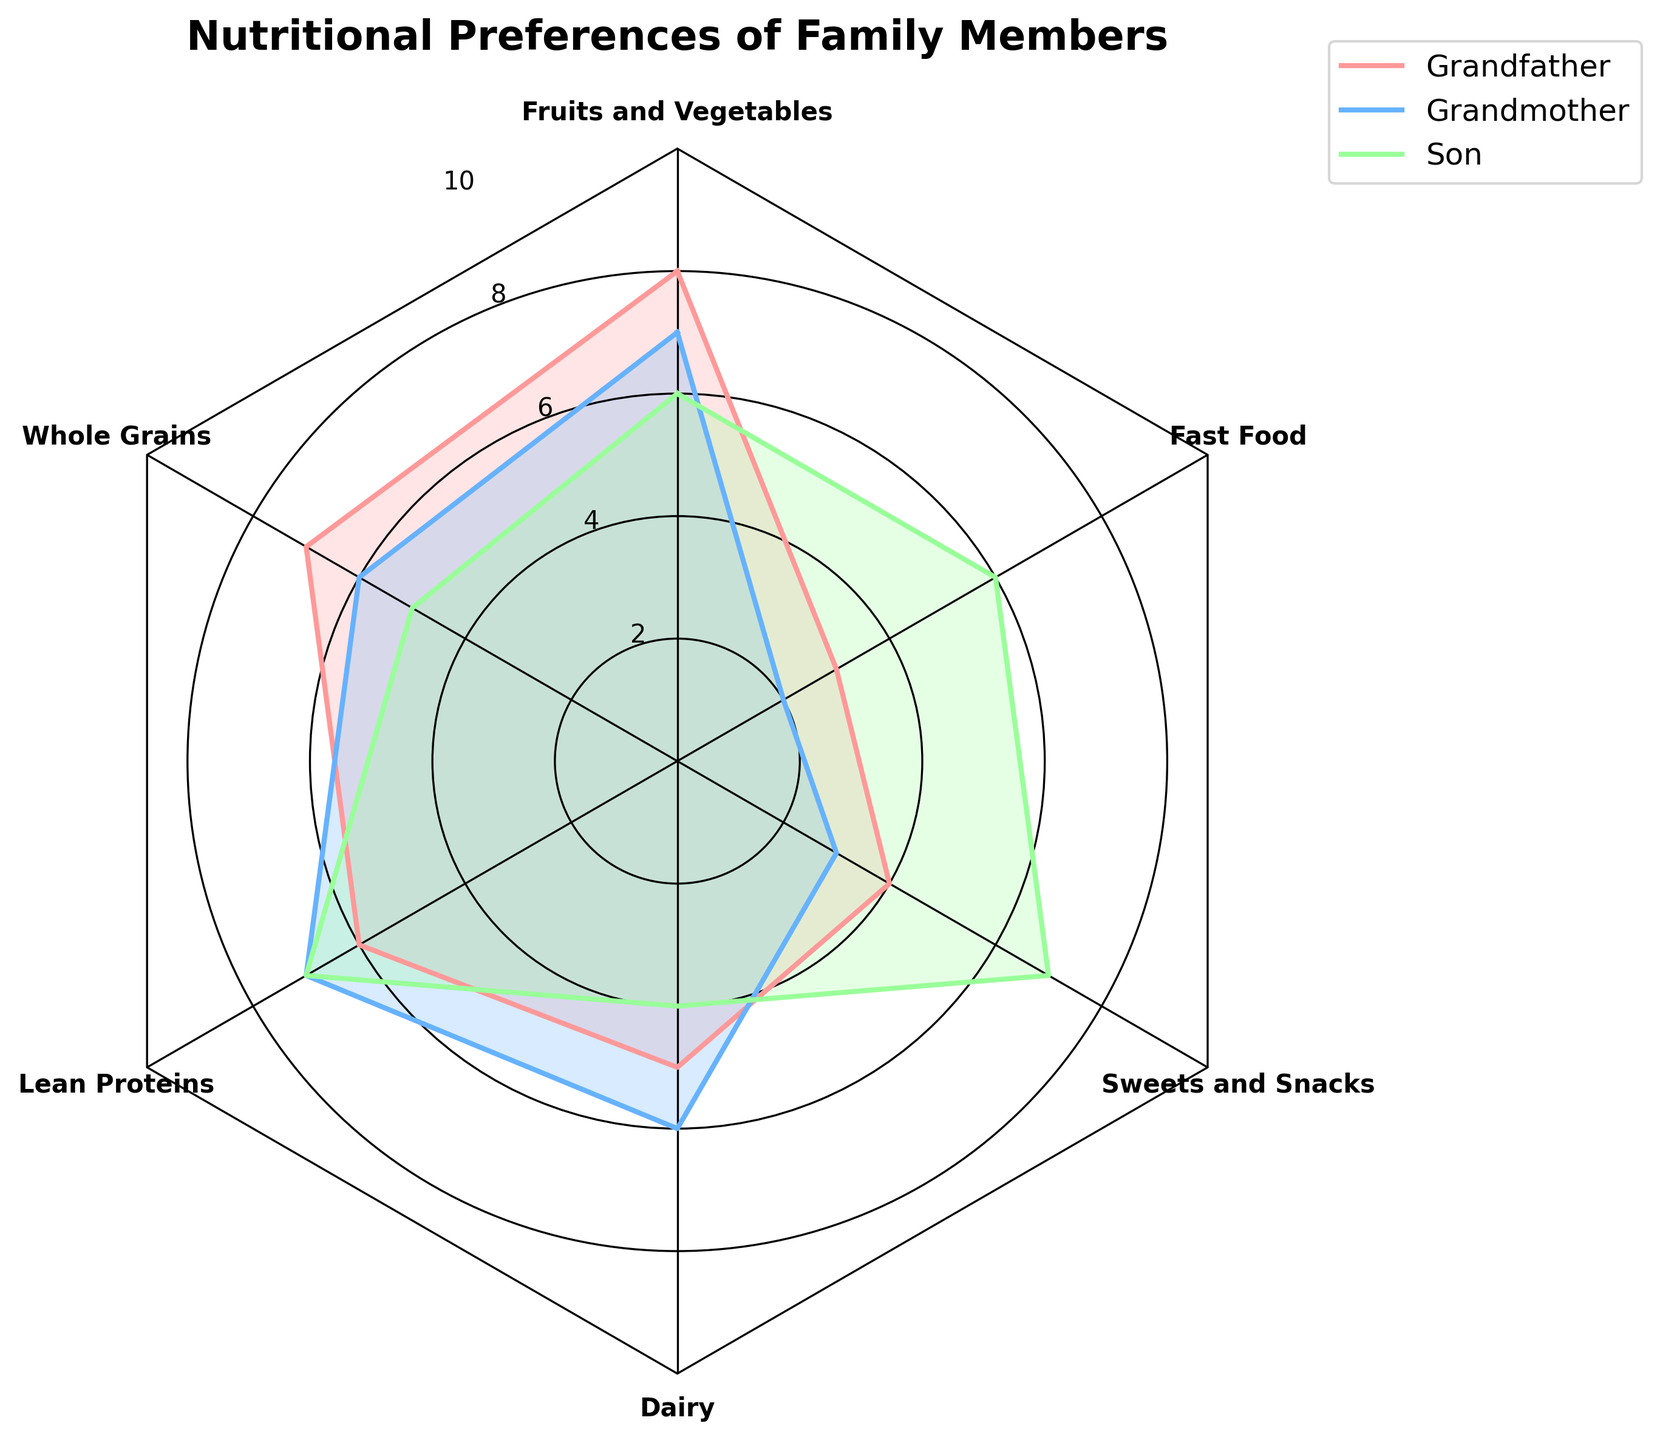How many nutritional preferences are compared in the chart? Count the number of different nutritional preferences listed around the chart.
Answer: 6 What is the highest value for any family member's preference? Identify the highest value among all preferences and family members.
Answer: 8 Which family member has the highest preference for fruits and vegetables? Look for the highest value at the "Fruits and Vegetables" point among all family members.
Answer: Grandfather What is the difference in preferences for fast food between the son and the daughter-in-law? Subtract the daughter's value from the son's value for fast food preference.
Answer: 1 Whose diet has the least preference for sweets and snacks? Find the family member with the lowest value for sweets and snacks.
Answer: Grandmother Which nutritional preference shows the largest range of values among family members? Compute the range (maximum value - minimum value) for each preference, and identify the largest range.
Answer: Fast Food Rank the family members from highest to lowest based on their preference for lean proteins. Compare and sort the values for lean proteins among all family members.
Answer: Grandmother, Son (tied); Grandfather, Daughter-in-Law Which family member has more balanced preferences, considering there are no extreme highs or lows? Identify the member with preferences closest in value across nutritional options, showing least variability.
Answer: Grandfather 